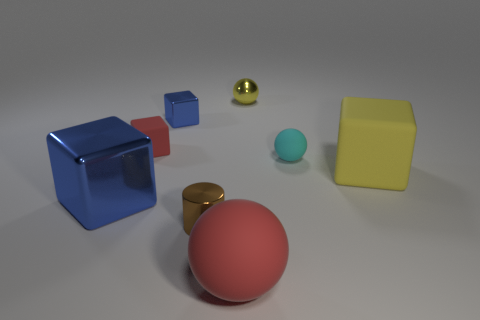The blue thing that is in front of the red object to the left of the small brown thing is made of what material?
Ensure brevity in your answer.  Metal. Are there any other things that are the same size as the red cube?
Ensure brevity in your answer.  Yes. Does the cylinder have the same size as the red matte block?
Make the answer very short. Yes. How many objects are either cubes that are on the left side of the tiny brown cylinder or red matte objects that are to the left of the small blue metallic object?
Make the answer very short. 3. Are there more tiny brown objects on the left side of the tiny red cube than small objects?
Provide a succinct answer. No. What number of other things are there of the same shape as the cyan rubber thing?
Provide a succinct answer. 2. There is a object that is in front of the small cyan rubber ball and to the right of the large red matte sphere; what is its material?
Provide a succinct answer. Rubber. How many things are big gray rubber cubes or tiny yellow balls?
Provide a short and direct response. 1. Are there more red matte things than green things?
Your answer should be compact. Yes. There is a yellow object in front of the tiny rubber object on the left side of the small yellow shiny ball; how big is it?
Keep it short and to the point. Large. 